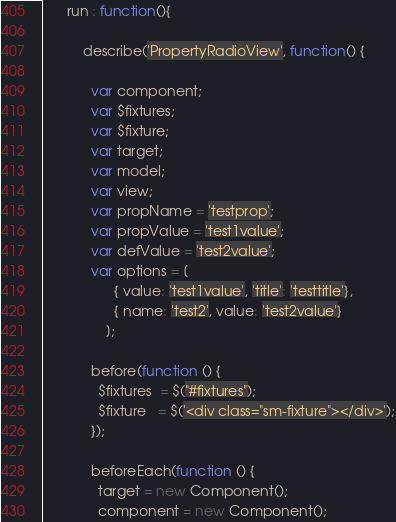Convert code to text. <code><loc_0><loc_0><loc_500><loc_500><_JavaScript_>      run : function(){

          describe('PropertyRadioView', function() {

            var component;
            var $fixtures;
            var $fixture;
            var target;
            var model;
            var view;
            var propName = 'testprop';
            var propValue = 'test1value';
            var defValue = 'test2value';
            var options = [
                  { value: 'test1value', 'title': 'testtitle'},
                  { name: 'test2', value: 'test2value'}
                ];

            before(function () {
              $fixtures  = $("#fixtures");
              $fixture   = $('<div class="sm-fixture"></div>');
            });

            beforeEach(function () {
              target = new Component();
              component = new Component();</code> 